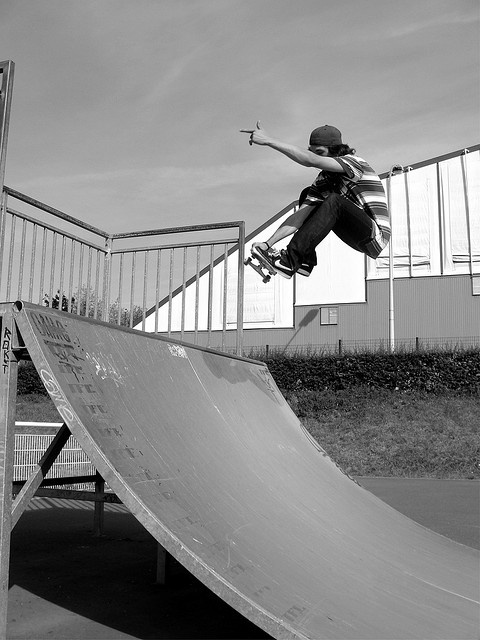Describe the objects in this image and their specific colors. I can see people in gray, black, darkgray, and lightgray tones and skateboard in gray, black, darkgray, and lightgray tones in this image. 